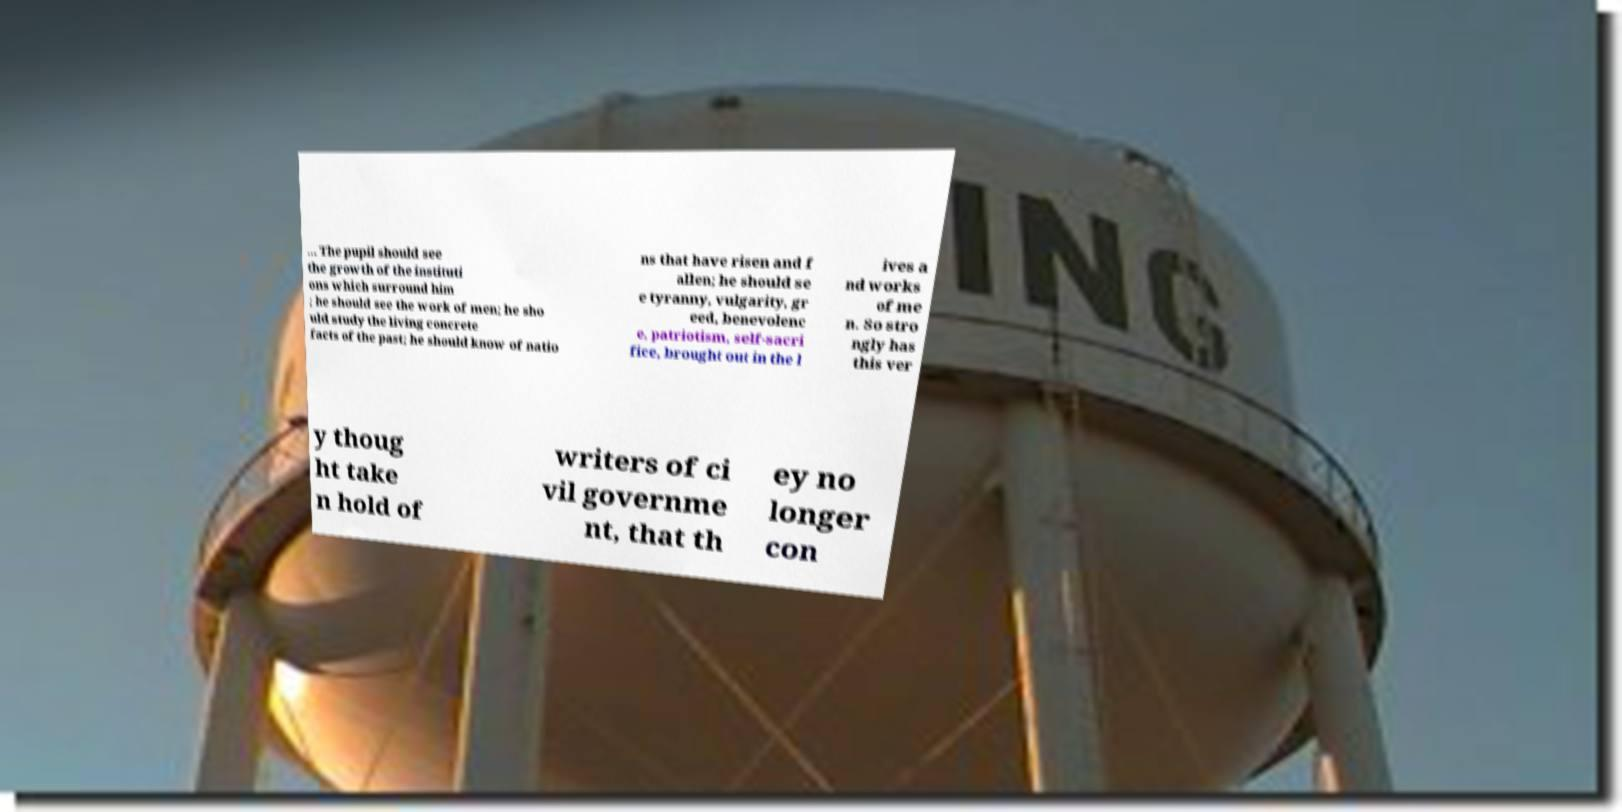Can you read and provide the text displayed in the image?This photo seems to have some interesting text. Can you extract and type it out for me? ... The pupil should see the growth of the instituti ons which surround him ; he should see the work of men; he sho uld study the living concrete facts of the past; he should know of natio ns that have risen and f allen; he should se e tyranny, vulgarity, gr eed, benevolenc e, patriotism, self-sacri fice, brought out in the l ives a nd works of me n. So stro ngly has this ver y thoug ht take n hold of writers of ci vil governme nt, that th ey no longer con 